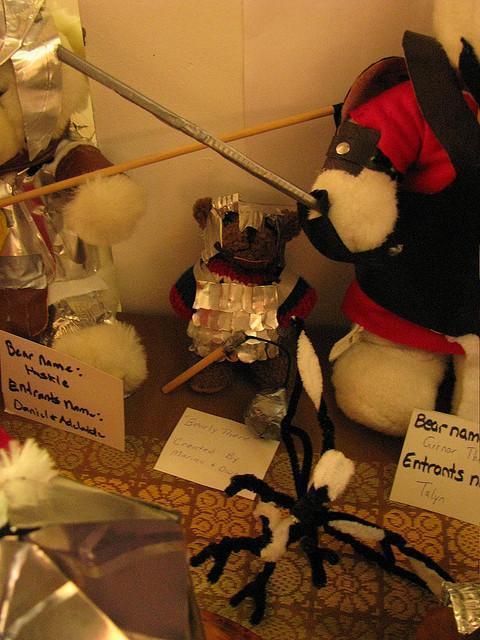How many teddy bears are there?
Give a very brief answer. 3. 